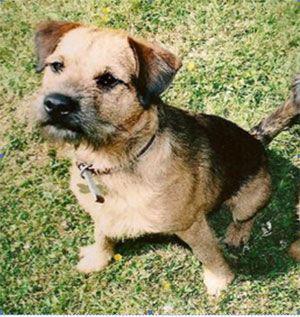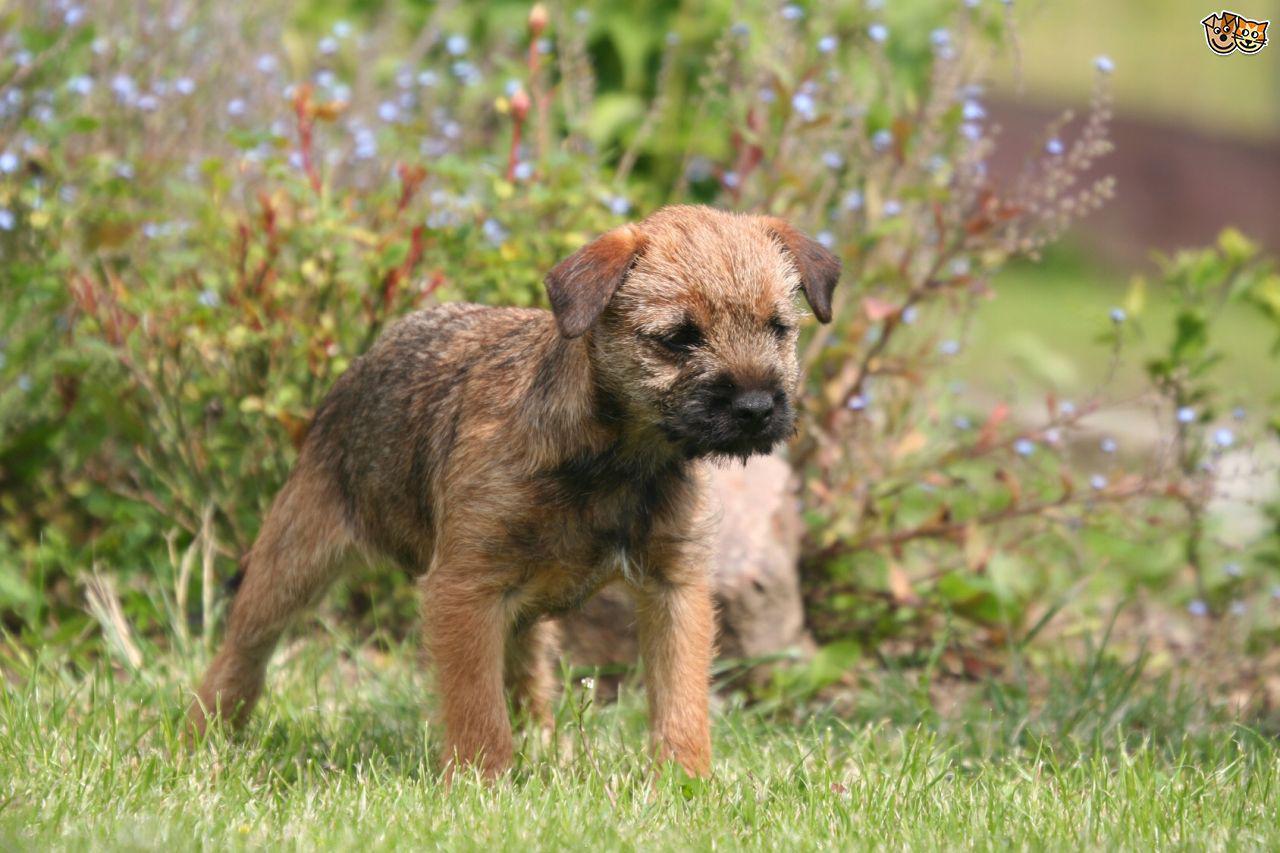The first image is the image on the left, the second image is the image on the right. Examine the images to the left and right. Is the description "The dogs are inside." accurate? Answer yes or no. No. The first image is the image on the left, the second image is the image on the right. Given the left and right images, does the statement "There are two dogs total outside in the grass." hold true? Answer yes or no. Yes. 